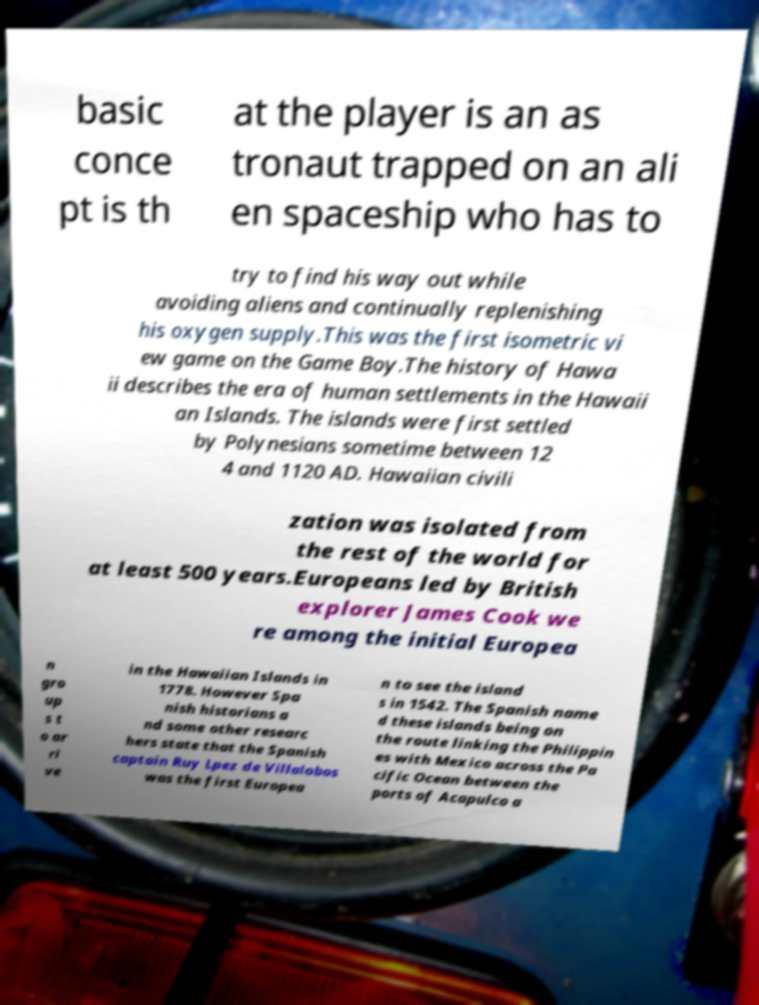There's text embedded in this image that I need extracted. Can you transcribe it verbatim? basic conce pt is th at the player is an as tronaut trapped on an ali en spaceship who has to try to find his way out while avoiding aliens and continually replenishing his oxygen supply.This was the first isometric vi ew game on the Game Boy.The history of Hawa ii describes the era of human settlements in the Hawaii an Islands. The islands were first settled by Polynesians sometime between 12 4 and 1120 AD. Hawaiian civili zation was isolated from the rest of the world for at least 500 years.Europeans led by British explorer James Cook we re among the initial Europea n gro up s t o ar ri ve in the Hawaiian Islands in 1778. However Spa nish historians a nd some other researc hers state that the Spanish captain Ruy Lpez de Villalobos was the first Europea n to see the island s in 1542. The Spanish name d these islands being on the route linking the Philippin es with Mexico across the Pa cific Ocean between the ports of Acapulco a 